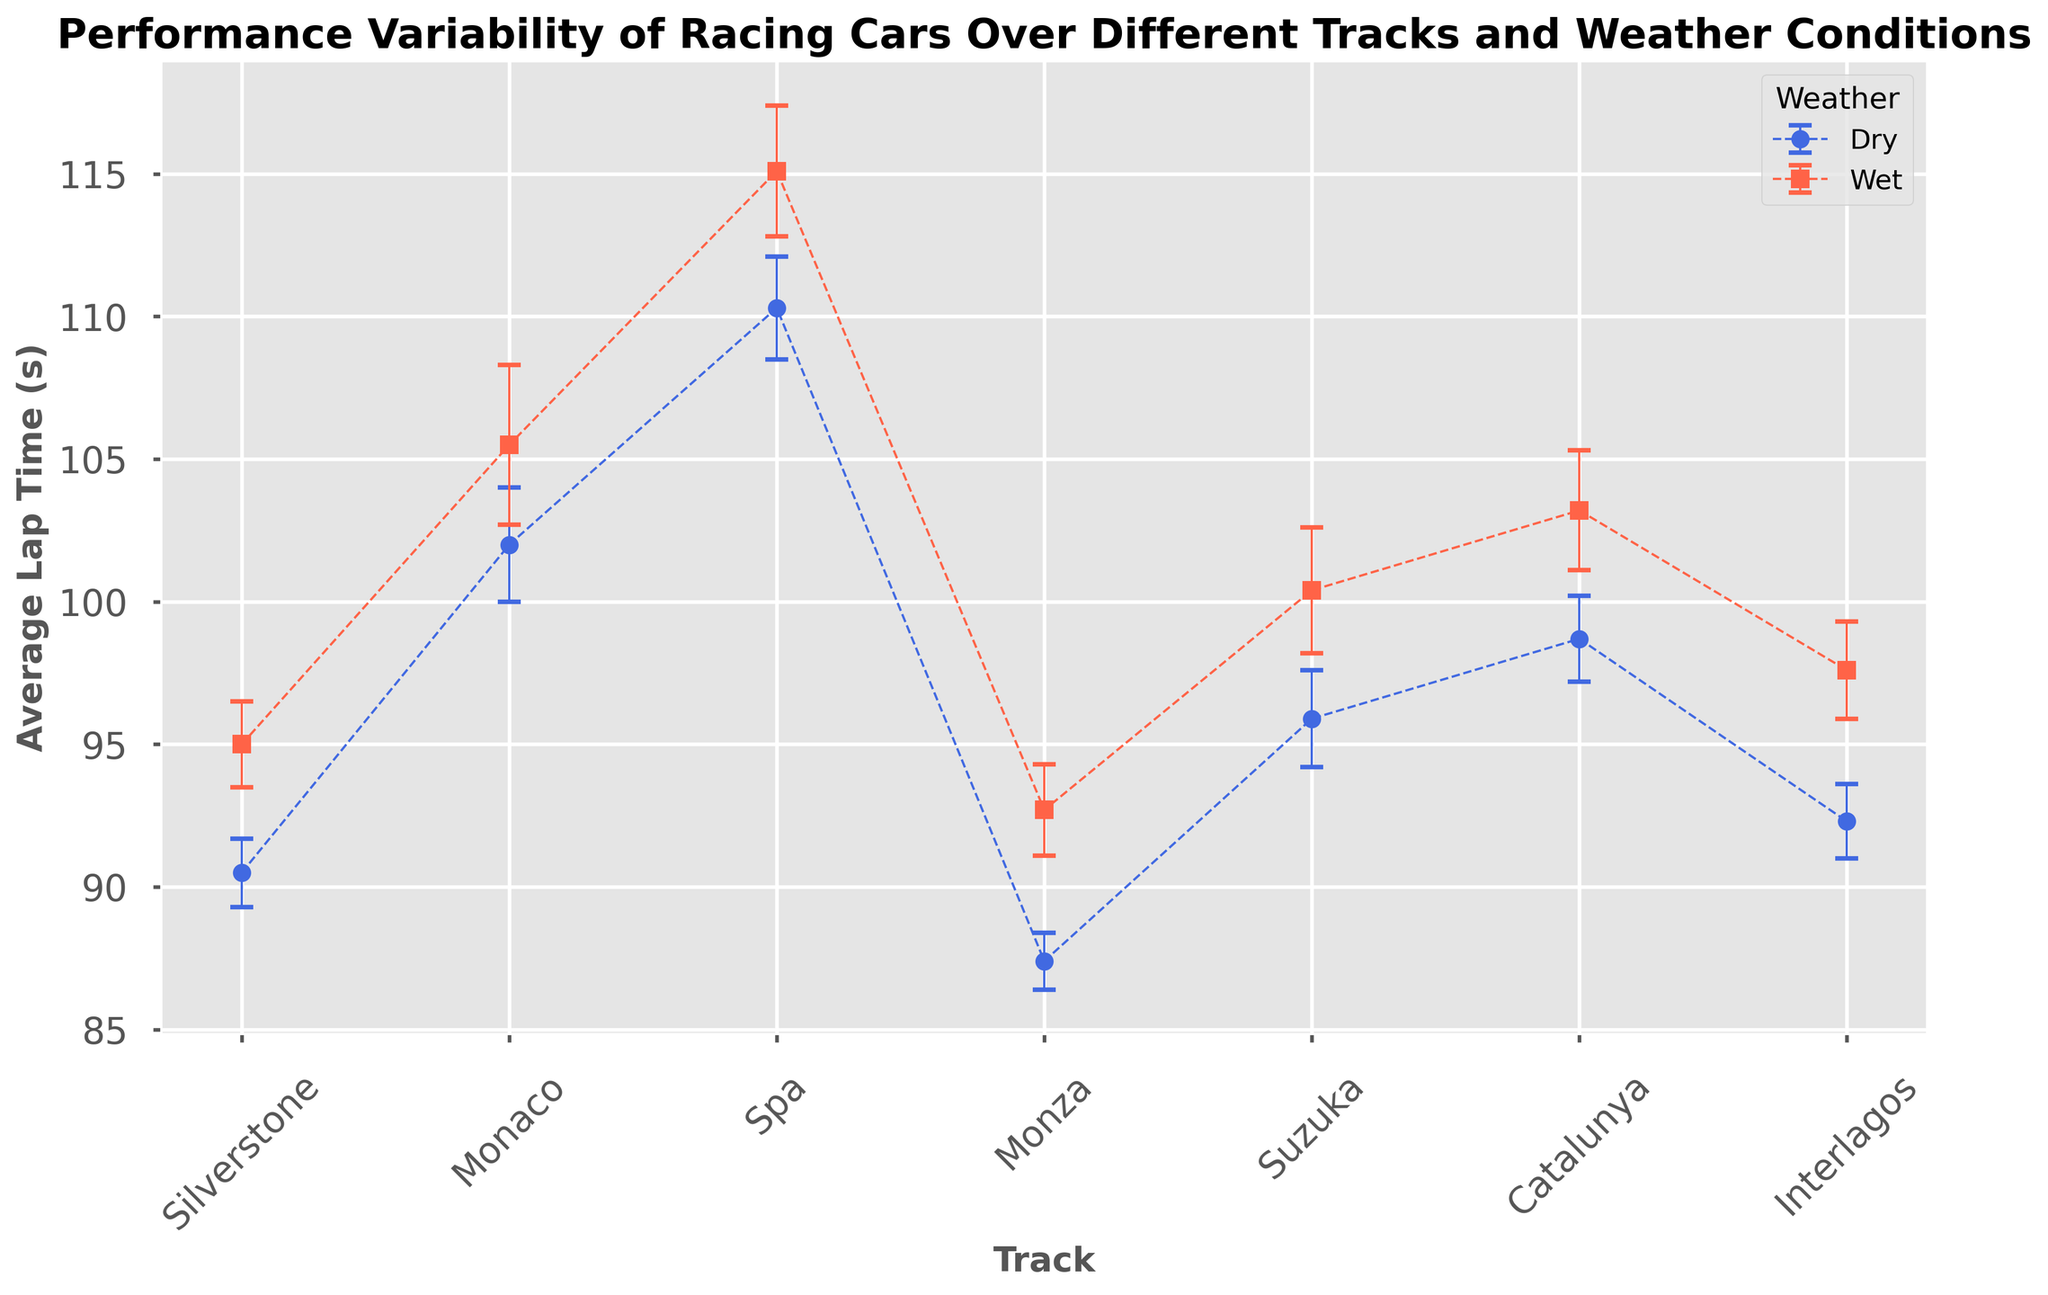What is the average lap time at Silverstone under dry conditions? The blue circles represent dry conditions, and the marker for Silverstone (the first one) shows an average lap time. Simply pick the value next to this marker.
Answer: 90.5s Which track has the highest average lap time in wet conditions? Look at the red squares representing wet conditions and identify the highest point among them.
Answer: Spa How much does the average lap time increase from dry to wet conditions at Monza? The average lap time at Monza in dry conditions is 87.4 seconds and in wet conditions is 92.7 seconds. The increase is 92.7 - 87.4.
Answer: 5.3s Which weather condition generally results in higher lap times across all tracks? Compare the positions of the red squares (wet) to the blue circles (dry) for all tracks. Red squares are consistently higher.
Answer: Wet What is the average of the dry lap times across all tracks? Sum all average lap times for dry conditions (90.5, 102.0, 110.3, 87.4, 95.9, 98.7, 92.3) and divide by the number of tracks (7). (90.5 + 102.0 + 110.3 + 87.4 + 95.9 + 98.7 + 92.3)/7 = 96.73.
Answer: 96.73s Which track shows the greatest variability in lap times under wet conditions? The track with the largest error bar in red (wet conditions) shows the greatest variability.
Answer: Monaco Is the standard deviation generally higher or lower in wet conditions compared to dry? Compare the length of the error bars for the red squares with those for the blue circles. Red squares generally have longer error bars.
Answer: Higher Which track shows the smallest increase in average lap time from dry to wet conditions? Calculate the difference in lap times from dry to wet for all tracks and find the smallest value. The smallest difference is at Silverstone: (95.0 - 90.5 = 4.5).
Answer: Silverstone 